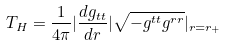<formula> <loc_0><loc_0><loc_500><loc_500>T _ { H } = \frac { 1 } { 4 \pi } | \frac { d g _ { t t } } { d r } | \sqrt { - g ^ { t t } g ^ { r r } } | _ { r = r _ { + } }</formula> 